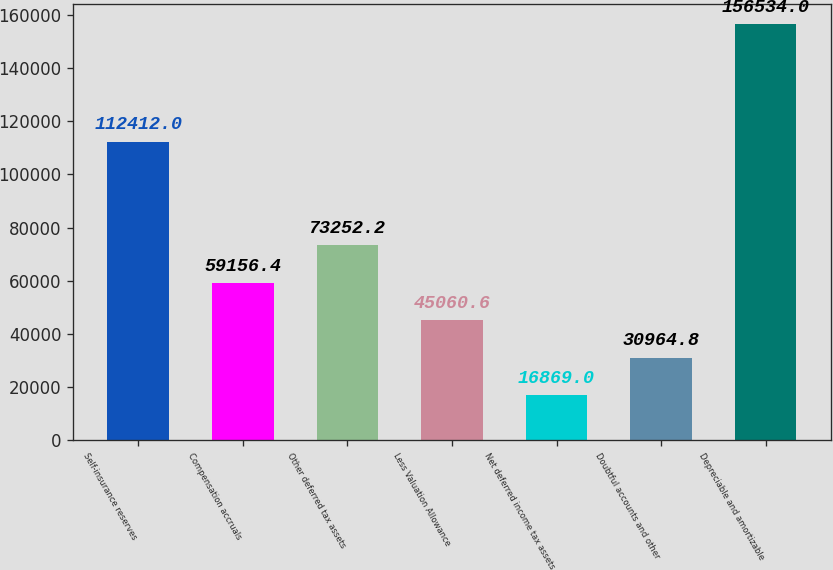<chart> <loc_0><loc_0><loc_500><loc_500><bar_chart><fcel>Self-insurance reserves<fcel>Compensation accruals<fcel>Other deferred tax assets<fcel>Less Valuation Allowance<fcel>Net deferred income tax assets<fcel>Doubtful accounts and other<fcel>Depreciable and amortizable<nl><fcel>112412<fcel>59156.4<fcel>73252.2<fcel>45060.6<fcel>16869<fcel>30964.8<fcel>156534<nl></chart> 